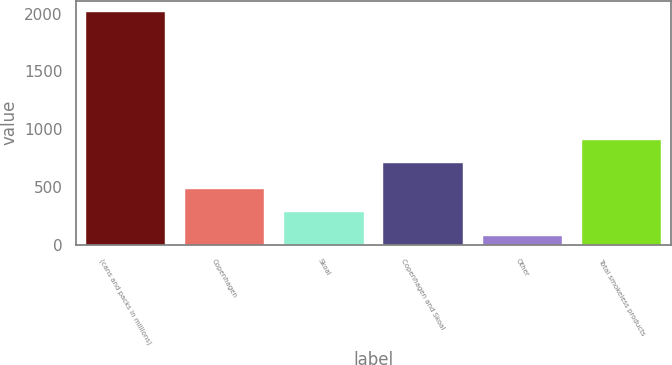Convert chart to OTSL. <chart><loc_0><loc_0><loc_500><loc_500><bar_chart><fcel>(cans and packs in millions)<fcel>Copenhagen<fcel>Skoal<fcel>Copenhagen and Skoal<fcel>Other<fcel>Total smokeless products<nl><fcel>2013<fcel>477.34<fcel>283.8<fcel>709.9<fcel>77.6<fcel>903.44<nl></chart> 